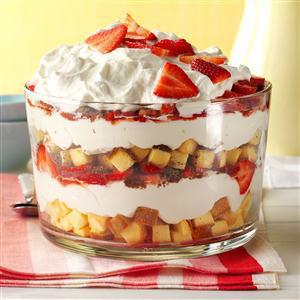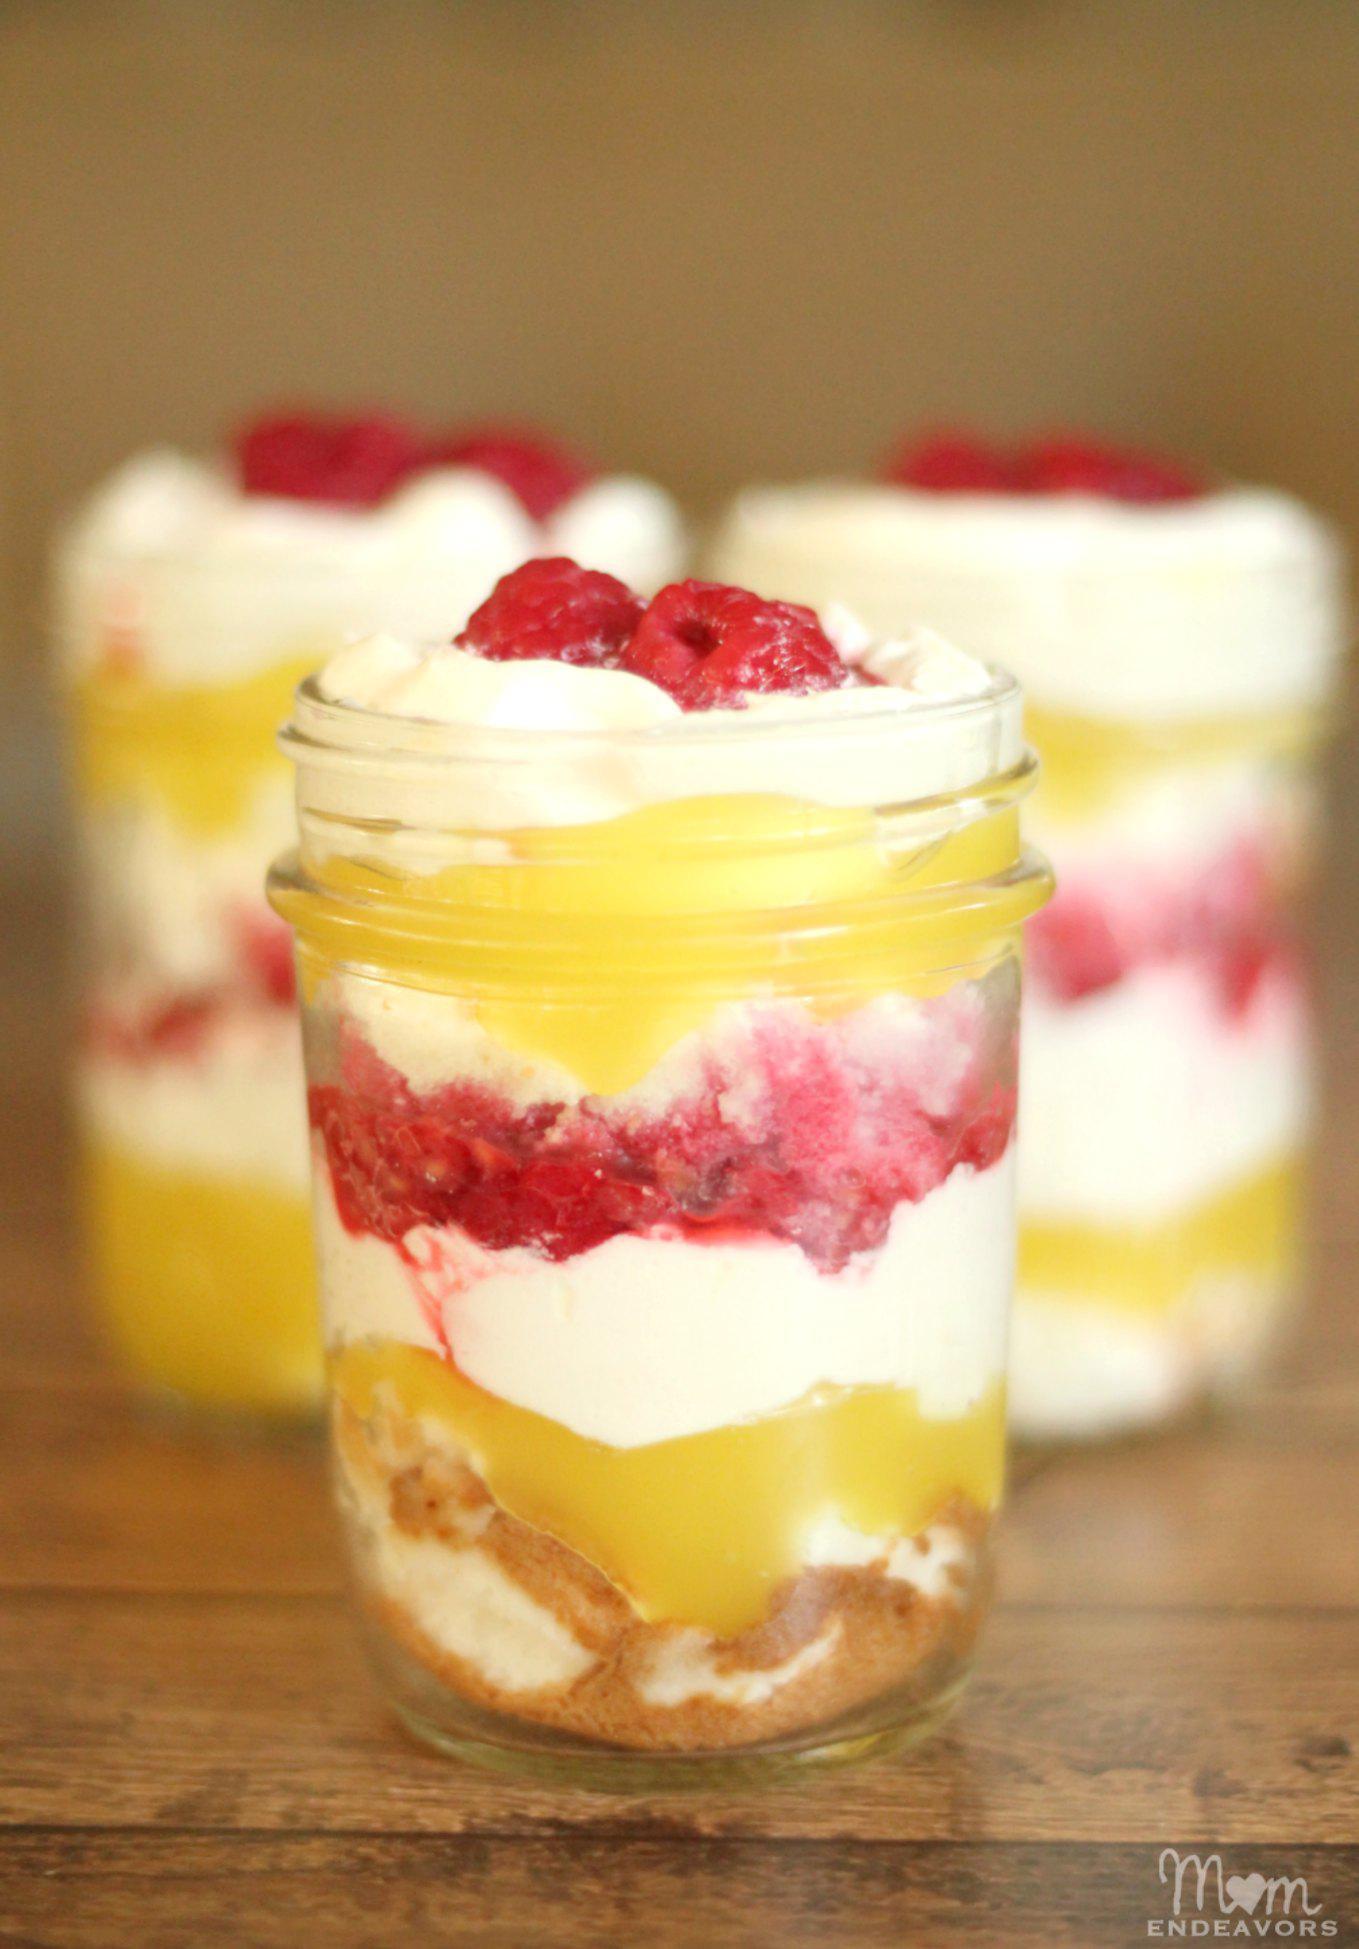The first image is the image on the left, the second image is the image on the right. Considering the images on both sides, is "There are lemon slices on top of a trifle in one of the images." valid? Answer yes or no. No. The first image is the image on the left, the second image is the image on the right. Examine the images to the left and right. Is the description "At least one image shows individual servings of layered dessert in non-footed glasses garnished with raspberries." accurate? Answer yes or no. Yes. 